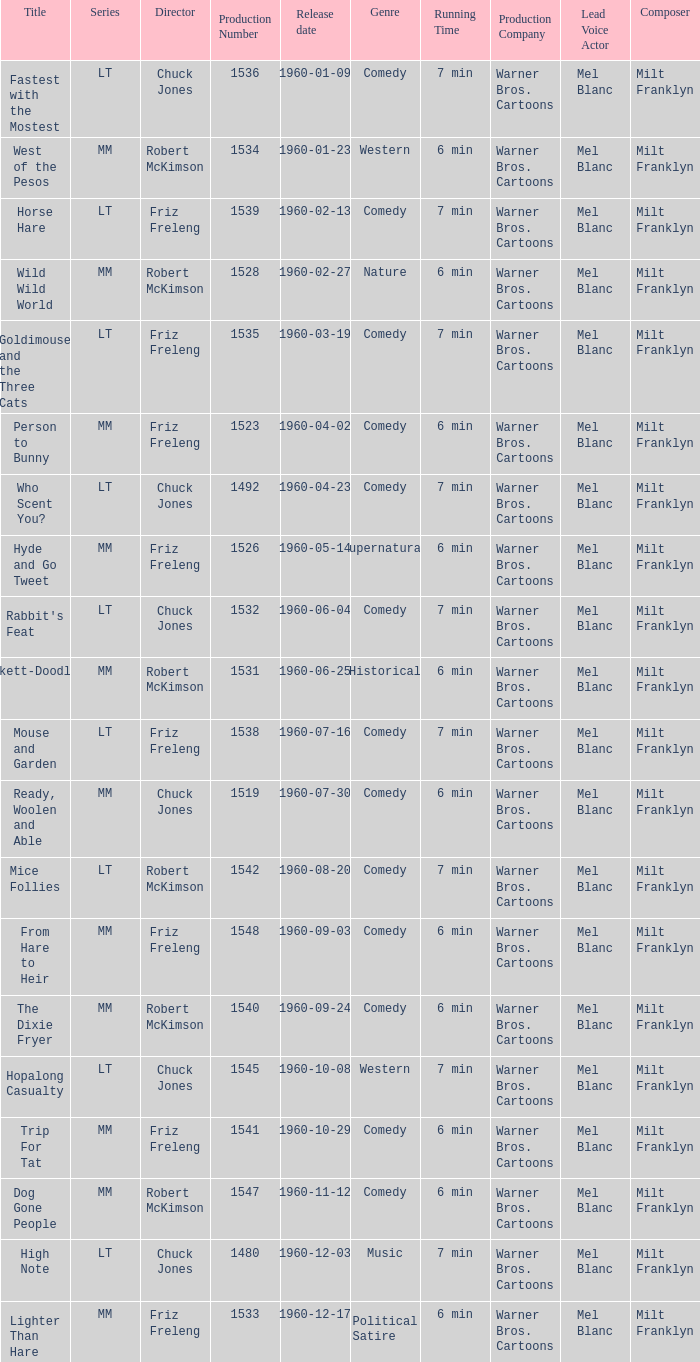What is the production number of From Hare to Heir? 1548.0. 